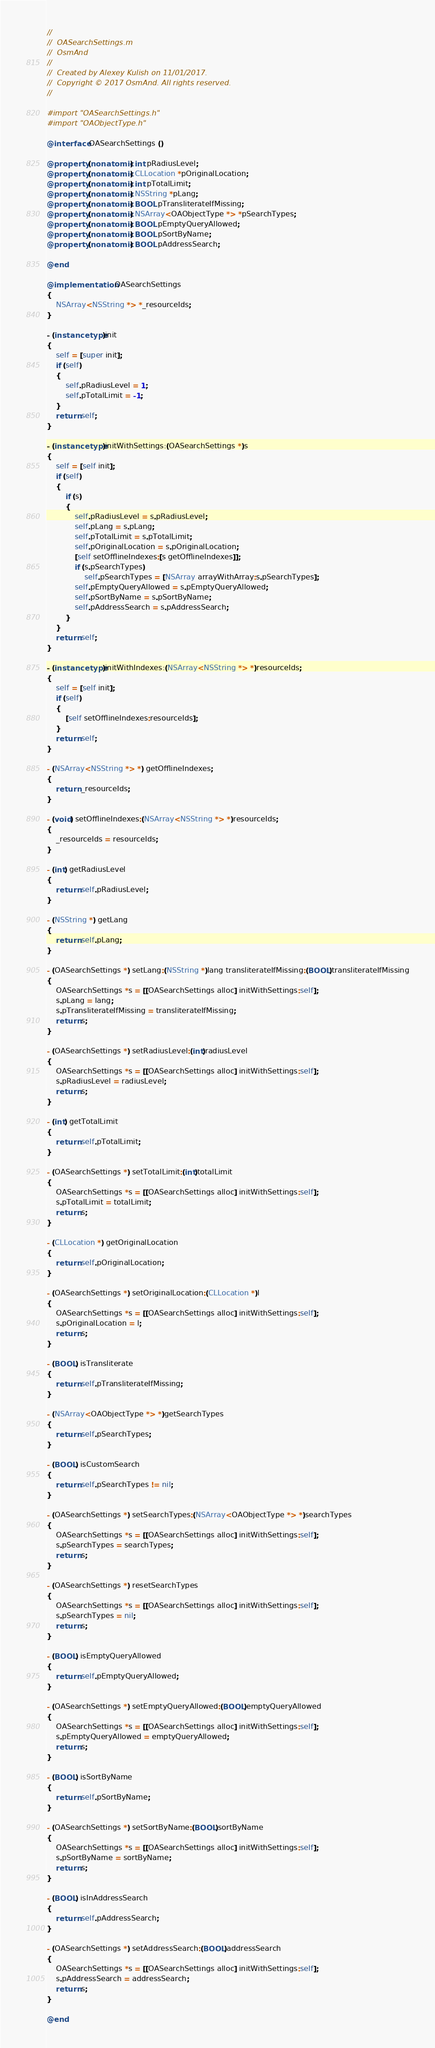<code> <loc_0><loc_0><loc_500><loc_500><_ObjectiveC_>//
//  OASearchSettings.m
//  OsmAnd
//
//  Created by Alexey Kulish on 11/01/2017.
//  Copyright © 2017 OsmAnd. All rights reserved.
//

#import "OASearchSettings.h"
#import "OAObjectType.h"

@interface OASearchSettings ()

@property (nonatomic) int pRadiusLevel;
@property (nonatomic) CLLocation *pOriginalLocation;
@property (nonatomic) int pTotalLimit;
@property (nonatomic) NSString *pLang;
@property (nonatomic) BOOL pTransliterateIfMissing;
@property (nonatomic) NSArray<OAObjectType *> *pSearchTypes;
@property (nonatomic) BOOL pEmptyQueryAllowed;
@property (nonatomic) BOOL pSortByName;
@property (nonatomic) BOOL pAddressSearch;

@end

@implementation OASearchSettings
{
    NSArray<NSString *> *_resourceIds;
}

- (instancetype)init
{
    self = [super init];
    if (self)
    {
        self.pRadiusLevel = 1;
        self.pTotalLimit = -1;
    }
    return self;
}

- (instancetype)initWithSettings:(OASearchSettings *)s
{
    self = [self init];
    if (self)
    {
        if (s)
        {
            self.pRadiusLevel = s.pRadiusLevel;
            self.pLang = s.pLang;
            self.pTotalLimit = s.pTotalLimit;
            self.pOriginalLocation = s.pOriginalLocation;
            [self setOfflineIndexes:[s getOfflineIndexes]];
            if (s.pSearchTypes)
                self.pSearchTypes = [NSArray arrayWithArray:s.pSearchTypes];
            self.pEmptyQueryAllowed = s.pEmptyQueryAllowed;
            self.pSortByName = s.pSortByName;
            self.pAddressSearch = s.pAddressSearch;
        }
    }
    return self;
}

- (instancetype)initWithIndexes:(NSArray<NSString *> *)resourceIds;
{
    self = [self init];
    if (self)
    {
        [self setOfflineIndexes:resourceIds];
    }
    return self;
}

- (NSArray<NSString *> *) getOfflineIndexes;
{
    return _resourceIds;
}

- (void) setOfflineIndexes:(NSArray<NSString *> *)resourceIds;
{
    _resourceIds = resourceIds;
}

- (int) getRadiusLevel
{
    return self.pRadiusLevel;
}

- (NSString *) getLang
{
    return self.pLang;
}

- (OASearchSettings *) setLang:(NSString *)lang transliterateIfMissing:(BOOL)transliterateIfMissing
{
    OASearchSettings *s = [[OASearchSettings alloc] initWithSettings:self];
    s.pLang = lang;
    s.pTransliterateIfMissing = transliterateIfMissing;
    return s;
}

- (OASearchSettings *) setRadiusLevel:(int)radiusLevel
{
    OASearchSettings *s = [[OASearchSettings alloc] initWithSettings:self];
    s.pRadiusLevel = radiusLevel;
    return s;
}

- (int) getTotalLimit
{
    return self.pTotalLimit;
}

- (OASearchSettings *) setTotalLimit:(int)totalLimit
{
    OASearchSettings *s = [[OASearchSettings alloc] initWithSettings:self];
    s.pTotalLimit = totalLimit;
    return s;
}

- (CLLocation *) getOriginalLocation
{
    return self.pOriginalLocation;
}

- (OASearchSettings *) setOriginalLocation:(CLLocation *)l
{
    OASearchSettings *s = [[OASearchSettings alloc] initWithSettings:self];
    s.pOriginalLocation = l;
    return s;
}

- (BOOL) isTransliterate
{
    return self.pTransliterateIfMissing;
}

- (NSArray<OAObjectType *> *)getSearchTypes
{
    return self.pSearchTypes;
}

- (BOOL) isCustomSearch
{
    return self.pSearchTypes != nil;
}

- (OASearchSettings *) setSearchTypes:(NSArray<OAObjectType *> *)searchTypes
{
    OASearchSettings *s = [[OASearchSettings alloc] initWithSettings:self];
    s.pSearchTypes = searchTypes;
    return s;
}

- (OASearchSettings *) resetSearchTypes
{
    OASearchSettings *s = [[OASearchSettings alloc] initWithSettings:self];
    s.pSearchTypes = nil;
    return s;
}

- (BOOL) isEmptyQueryAllowed
{
    return self.pEmptyQueryAllowed;
}

- (OASearchSettings *) setEmptyQueryAllowed:(BOOL)emptyQueryAllowed
{
    OASearchSettings *s = [[OASearchSettings alloc] initWithSettings:self];
    s.pEmptyQueryAllowed = emptyQueryAllowed;
    return s;
}

- (BOOL) isSortByName
{
    return self.pSortByName;
}

- (OASearchSettings *) setSortByName:(BOOL)sortByName
{
    OASearchSettings *s = [[OASearchSettings alloc] initWithSettings:self];
    s.pSortByName = sortByName;
    return s;
}

- (BOOL) isInAddressSearch
{
    return self.pAddressSearch;
}

- (OASearchSettings *) setAddressSearch:(BOOL)addressSearch
{
    OASearchSettings *s = [[OASearchSettings alloc] initWithSettings:self];
    s.pAddressSearch = addressSearch;
    return s;
}

@end
</code> 